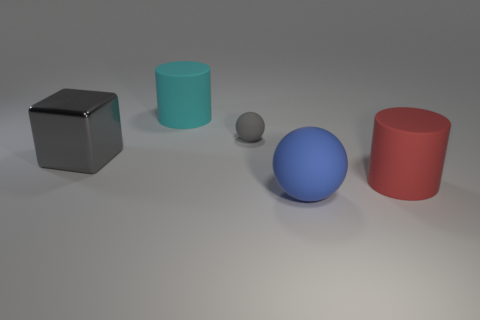Is there anything else that is the same size as the gray rubber thing?
Offer a very short reply. No. There is a small ball that is the same color as the large block; what is it made of?
Offer a terse response. Rubber. What is the material of the large thing that is in front of the large cyan matte cylinder and left of the gray matte ball?
Give a very brief answer. Metal. There is a metallic object left of the tiny gray matte thing; is there a big metallic thing that is in front of it?
Ensure brevity in your answer.  No. What size is the matte thing that is behind the big sphere and in front of the gray matte thing?
Give a very brief answer. Large. How many gray things are either small rubber things or metal cubes?
Keep it short and to the point. 2. What shape is the red object that is the same size as the cyan cylinder?
Your response must be concise. Cylinder. What number of other things are there of the same color as the shiny thing?
Provide a short and direct response. 1. How big is the cylinder right of the large blue ball that is in front of the small gray matte object?
Keep it short and to the point. Large. Is the big cylinder in front of the large cyan rubber object made of the same material as the large gray block?
Your response must be concise. No. 